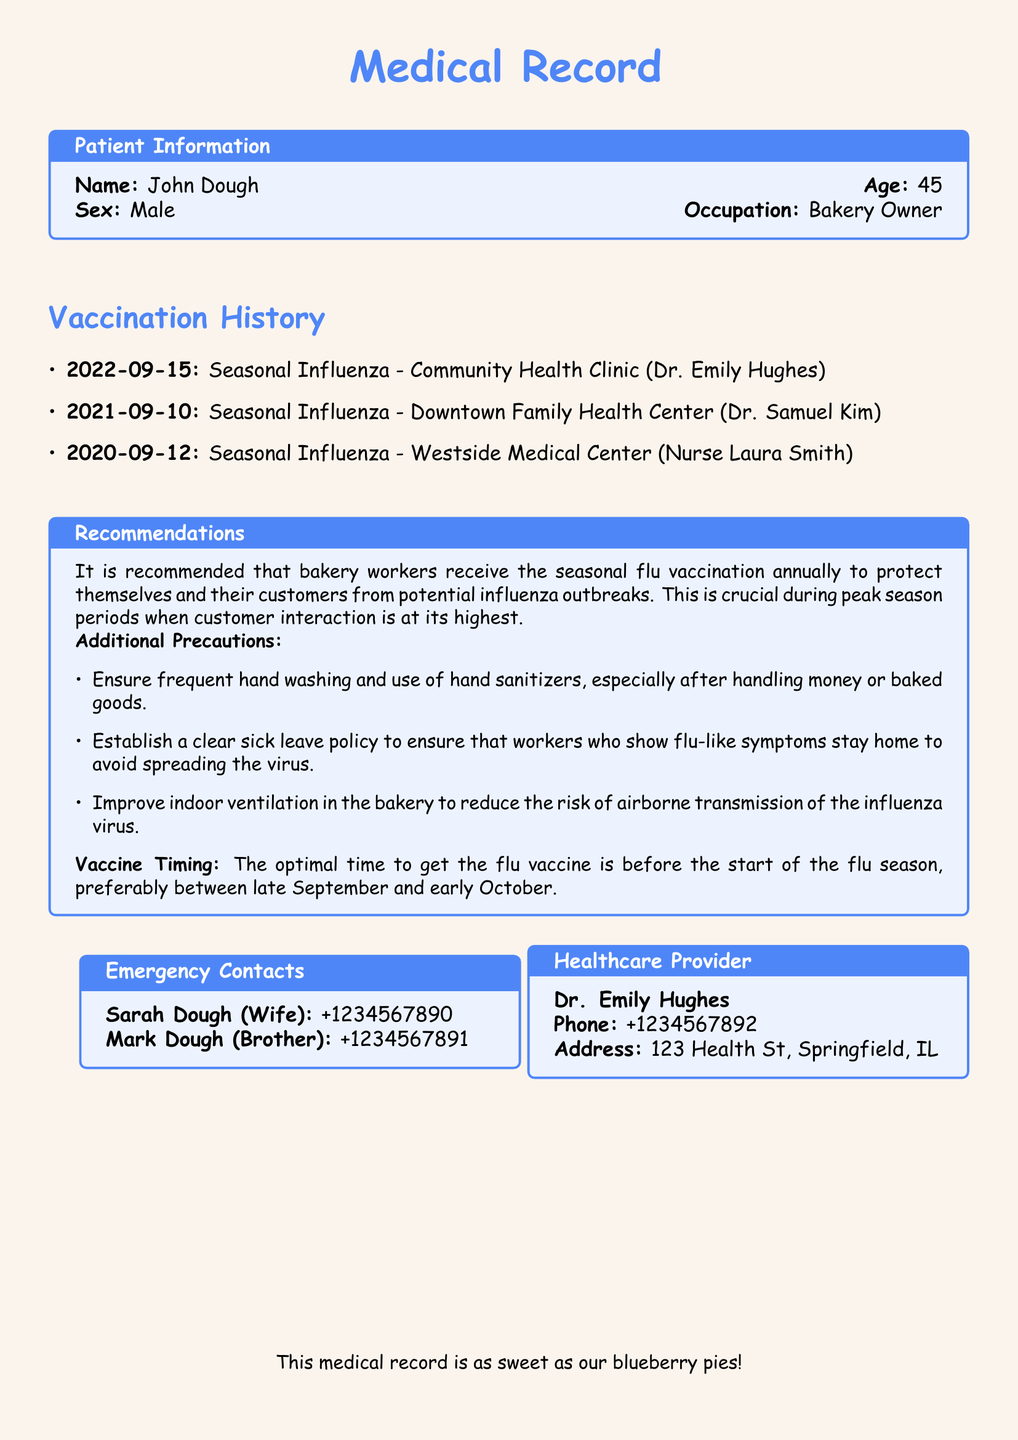What is the patient's name? The document provides patient information including the name John Dough.
Answer: John Dough What is the patient's occupation? The occupation of the patient, as stated in the document, is Bakery Owner.
Answer: Bakery Owner When was the last influenza vaccination received? The most recent vaccination date listed is September 15, 2022.
Answer: 2022-09-15 Who administered the last vaccine? The document specifies that Dr. Emily Hughes administered the last vaccination.
Answer: Dr. Emily Hughes What is the optimal time to get the flu vaccine? The document states the optimal time is between late September and early October.
Answer: Late September and early October What are the additional precautions recommended for bakery workers? The document outlines several precautions, specifically recommending frequent hand washing and the use of hand sanitizers.
Answer: Frequent hand washing and use of hand sanitizers How many flu vaccinations has John Dough received? The vaccination history lists three separate vaccination dates, indicating three vaccinations.
Answer: Three What should be done if a bakery worker shows flu-like symptoms? The document recommends having a clear sick leave policy for such cases.
Answer: Clear sick leave policy What is the name of the healthcare provider? Dr. Emily Hughes is listed as the healthcare provider in the document.
Answer: Dr. Emily Hughes 